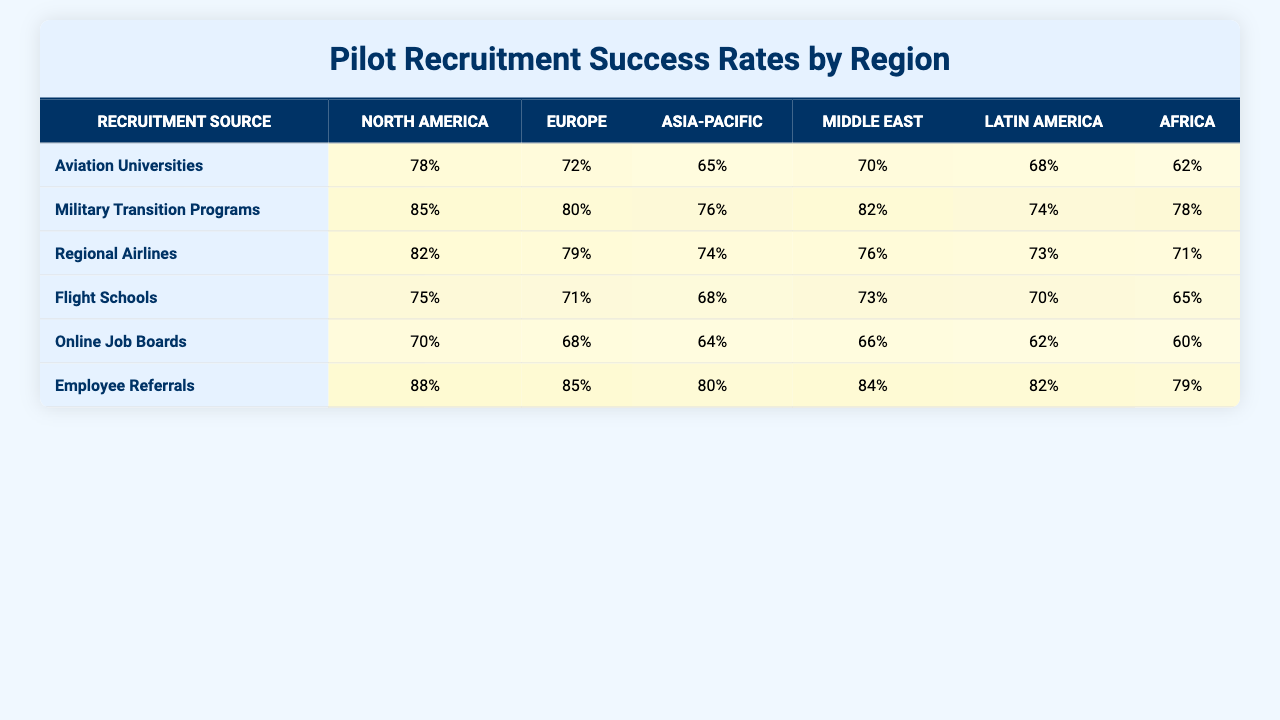What is the hiring success rate for pilots from Aviation Universities in North America? According to the table, the hiring success rate for pilots from Aviation Universities in North America is 78%.
Answer: 78% Which recruitment source has the highest success rate in Europe? By looking at the table, Employee Referrals has the highest success rate in Europe at 85%.
Answer: 85% What is the average hiring success rate for pilots from Regional Airlines across all regions? The hiring success rates for Regional Airlines are 82% (North America), 79% (Europe), 74% (Asia-Pacific), 76% (Middle East), 73% (Latin America), and 71% (Africa). Summing these gives 455%, and dividing by 6 gives an average of 75.83%.
Answer: 75.83% Is the hiring success rate for Flight Schools in Asia-Pacific greater than 70%? The table shows that the success rate for Flight Schools in Asia-Pacific is 68%, which is less than 70%.
Answer: No Which recruitment source has a higher success rate in Latin America: Military Transition Programs or Aviation Universities? Military Transition Programs have a success rate of 74% in Latin America, while Aviation Universities have a success rate of 68%. Since 74% is greater than 68%, Military Transition Programs have a higher rate.
Answer: Military Transition Programs What is the difference in hiring success rates between Employee Referrals and Online Job Boards in North America? Employee Referrals have a success rate of 88% while Online Job Boards have a success rate of 70% in North America. Calculating the difference gives 88% - 70% = 18%.
Answer: 18% In which region do Flight Schools have the lowest success rate? The table shows that Flight Schools have their lowest success rate in Africa at 65%.
Answer: Africa What is the combined success rate from Military Transition Programs and Employee Referrals in the Middle East? The success rate from Military Transition Programs in the Middle East is 82%, and from Employee Referrals it is 84%. Summing these gives 82% + 84% = 166%.
Answer: 166% Are Aviation Universities consistently a successful recruitment source across all regions? The success rates for Aviation Universities across regions are: 78% (North America), 72% (Europe), 65% (Asia-Pacific), 70% (Middle East), 68% (Latin America), and 62% (Africa). While they perform well, the rates do show a decline, especially in Africa.
Answer: No Which region shows the best absolute success rate across all recruitment sources? Evaluating the highest success rates from the table: North America has Employee Referrals at 88%, Europe has Employee Referrals at 85%, and others show lower figures. Therefore, North America shows the highest absolute success rate at 88%.
Answer: North America 